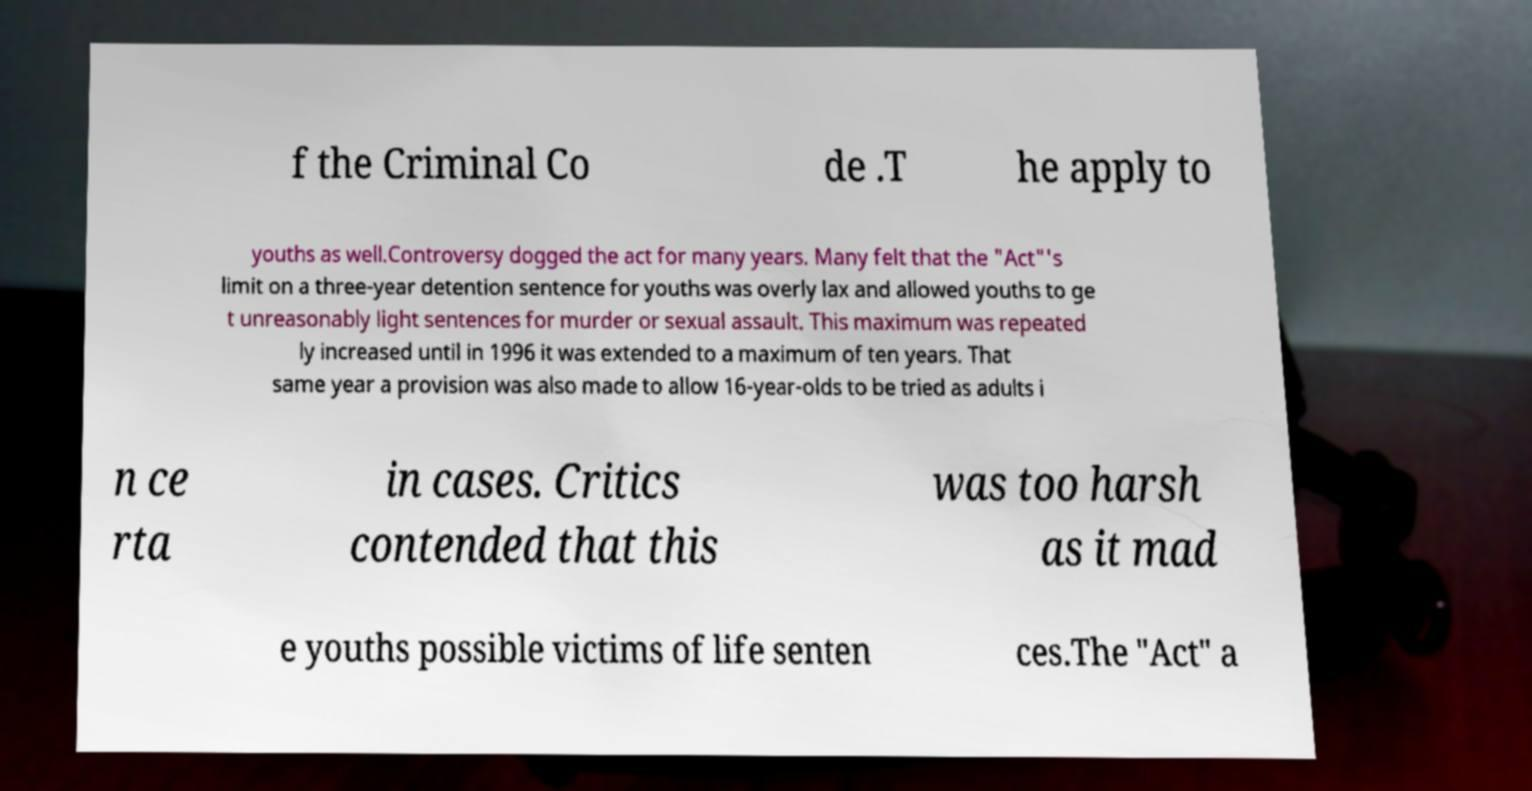Could you extract and type out the text from this image? f the Criminal Co de .T he apply to youths as well.Controversy dogged the act for many years. Many felt that the "Act"'s limit on a three-year detention sentence for youths was overly lax and allowed youths to ge t unreasonably light sentences for murder or sexual assault. This maximum was repeated ly increased until in 1996 it was extended to a maximum of ten years. That same year a provision was also made to allow 16-year-olds to be tried as adults i n ce rta in cases. Critics contended that this was too harsh as it mad e youths possible victims of life senten ces.The "Act" a 